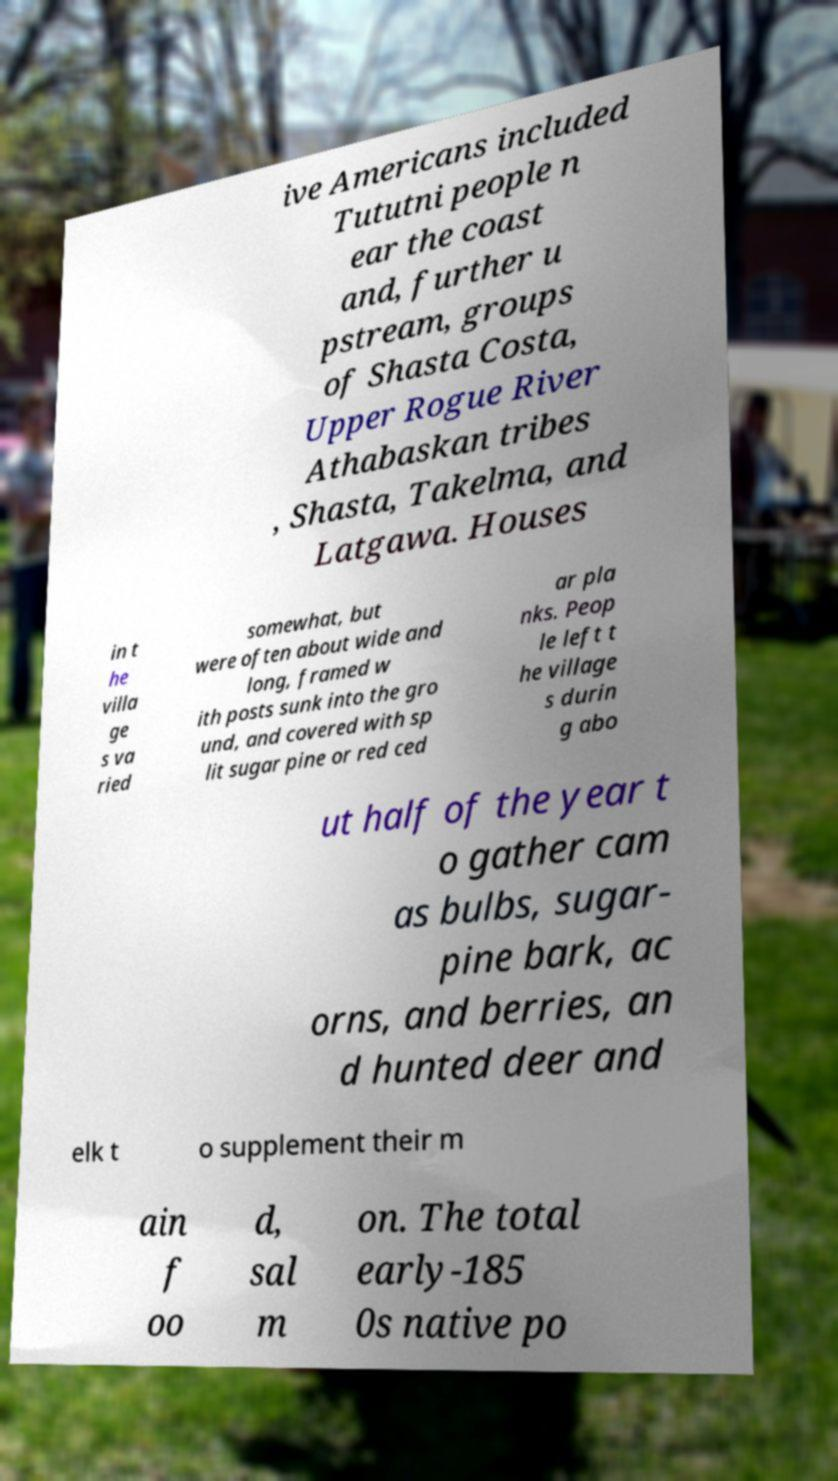For documentation purposes, I need the text within this image transcribed. Could you provide that? ive Americans included Tututni people n ear the coast and, further u pstream, groups of Shasta Costa, Upper Rogue River Athabaskan tribes , Shasta, Takelma, and Latgawa. Houses in t he villa ge s va ried somewhat, but were often about wide and long, framed w ith posts sunk into the gro und, and covered with sp lit sugar pine or red ced ar pla nks. Peop le left t he village s durin g abo ut half of the year t o gather cam as bulbs, sugar- pine bark, ac orns, and berries, an d hunted deer and elk t o supplement their m ain f oo d, sal m on. The total early-185 0s native po 